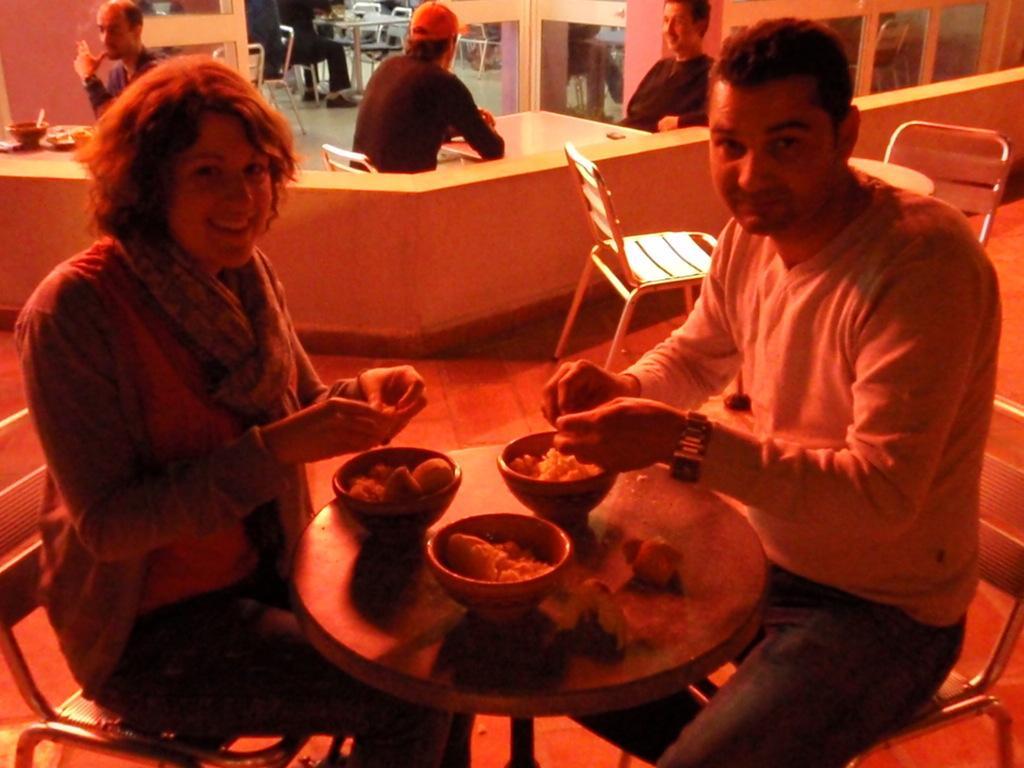How would you summarize this image in a sentence or two? In this image i can see a woman and a man sitting on chairs in front of a table, On the table i can see 3 bowls with food items in them. In the background i can see few empty chairs, two persons sitting on chairs, a table and a wall. 